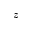Convert formula to latex. <formula><loc_0><loc_0><loc_500><loc_500>z</formula> 